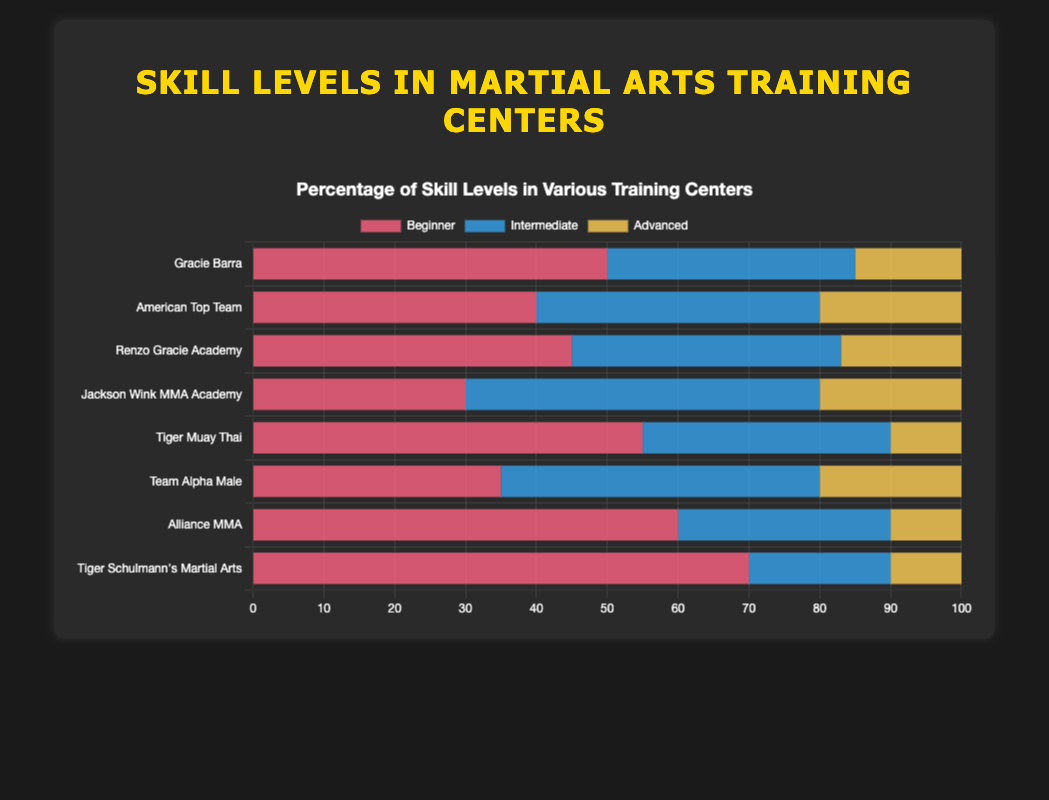Which training center has the highest percentage of beginners? The training center with the highest percentage of beginners is the one with the longest bar segment in the section designated for beginners. In the figure, this is "Tiger Schulmann's Martial Arts" with 70%.
Answer: Tiger Schulmann's Martial Arts Which training center has more advanced trainees, Renzo Gracie Academy or Jackson Wink MMA Academy? By comparing the yellow segments (representing advanced trainees) of both training centers, Renzo Gracie Academy has 17%, while Jackson Wink MMA Academy has 20%. Thus, Jackson Wink MMA Academy has more advanced trainees.
Answer: Jackson Wink MMA Academy Calculate the average percentage of intermediate trainees across all training centers. Sum the percentages of intermediate trainees for all training centers: 35 + 40 + 38 + 50+ 35 + 45 + 30 + 20 = 293. There are 8 training centers, so the average is 293 / 8.
Answer: 36.63 Which training center has the least diversity in skill levels? The training center with the least diversity in skill levels can be determined by the most uneven distribution of bar segments. "Tiger Schulmann’s Martial Arts" has 70% beginners, 20% intermediate, and 10% advanced, indicating high concentration in beginners and less diversity.
Answer: Tiger Schulmann’s Martial Arts Compare the percentage of beginner and advanced trainees in Team Alpha Male. Is the percentage of beginners significantly higher? The red segment for beginners in Team Alpha Male is 35%, while the yellow segment for advanced is 20%. Therefore, beginners are higher by 15%.
Answer: Yes Which training centers have an equal percentage of advanced trainees? Look for training centers with equal lengths for the yellow segments representing advanced trainees. Both American Top Team, Jackson Wink MMA Academy, and Team Alpha Male have 20% advanced trainees.
Answer: American Top Team, Jackson Wink MMA Academy, Team Alpha Male Rank the training centers from highest to lowest in terms of intermediate trainees. By observing the blue segments representing intermediate trainees: 1) Jackson Wink MMA Academy (50%), 2) Team Alpha Male (45%), 3) Gracie Barra and Tiger Muay Thai (35%), 4) Renzo Gracie Academy (38%), 5) American Top Team (40%), 6) Alliance MMA (30%), 7) Tiger Schulmann’s Martial Arts (20%).
Answer: Jackson Wink MMA Academy, Team Alpha Male, American Top Team, Renzo Gracie Academy, Gracie Barra, Tiger Muay Thai, Alliance MMA, Tiger Schulmann’s Martial Arts What is the total percentage of advanced trainees in all training centers combined? Summing up the percentages of advanced trainees for all training centers: 15 + 20 + 17 + 20 + 10 + 20 + 10 + 10 = 122%.
Answer: 122% Which color segment represents the intermediate skill level and which training center has the highest percentage of intermediate trainees? The blue color segment represents intermediate skill level. Jackson Wink MMA Academy has the highest percentage of intermediate trainees at 50%.
Answer: Blue, Jackson Wink MMA Academy 